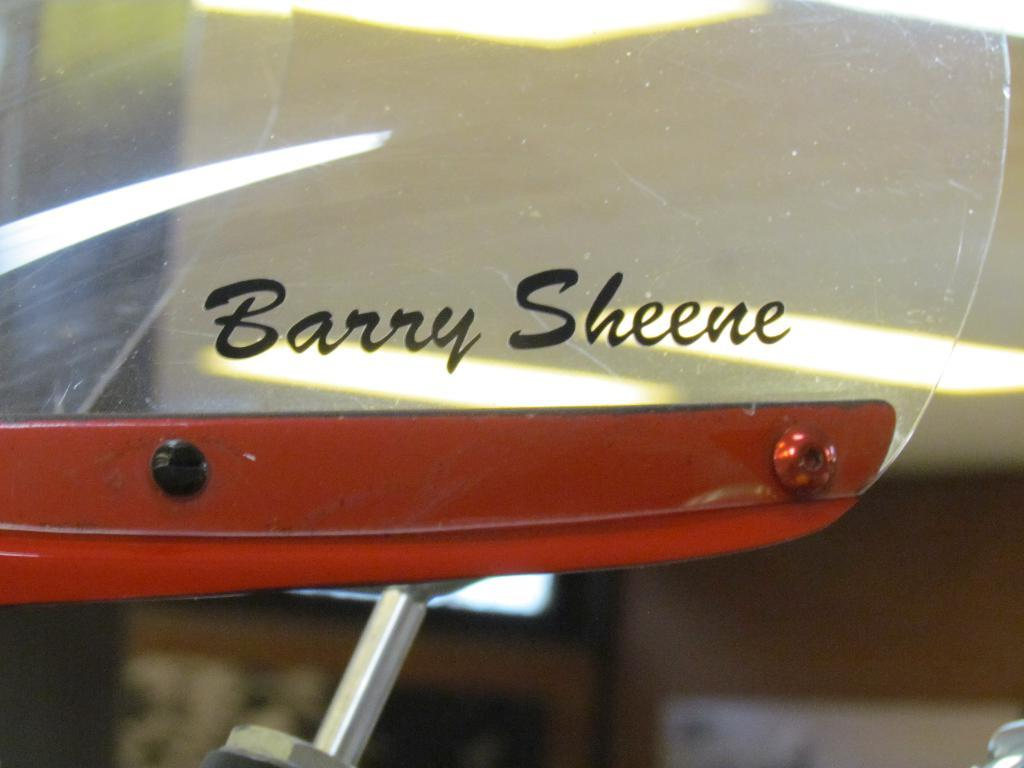What object is present in the image that can be used for reflection? There is a mirror in the image. Is there any text or writing on the mirror? Yes, the name "BARRY SHEENE" is printed on the mirror. Who is the creator of the operation depicted in the image? There is no operation depicted in the image, so it is not possible to determine who the creator might be. 